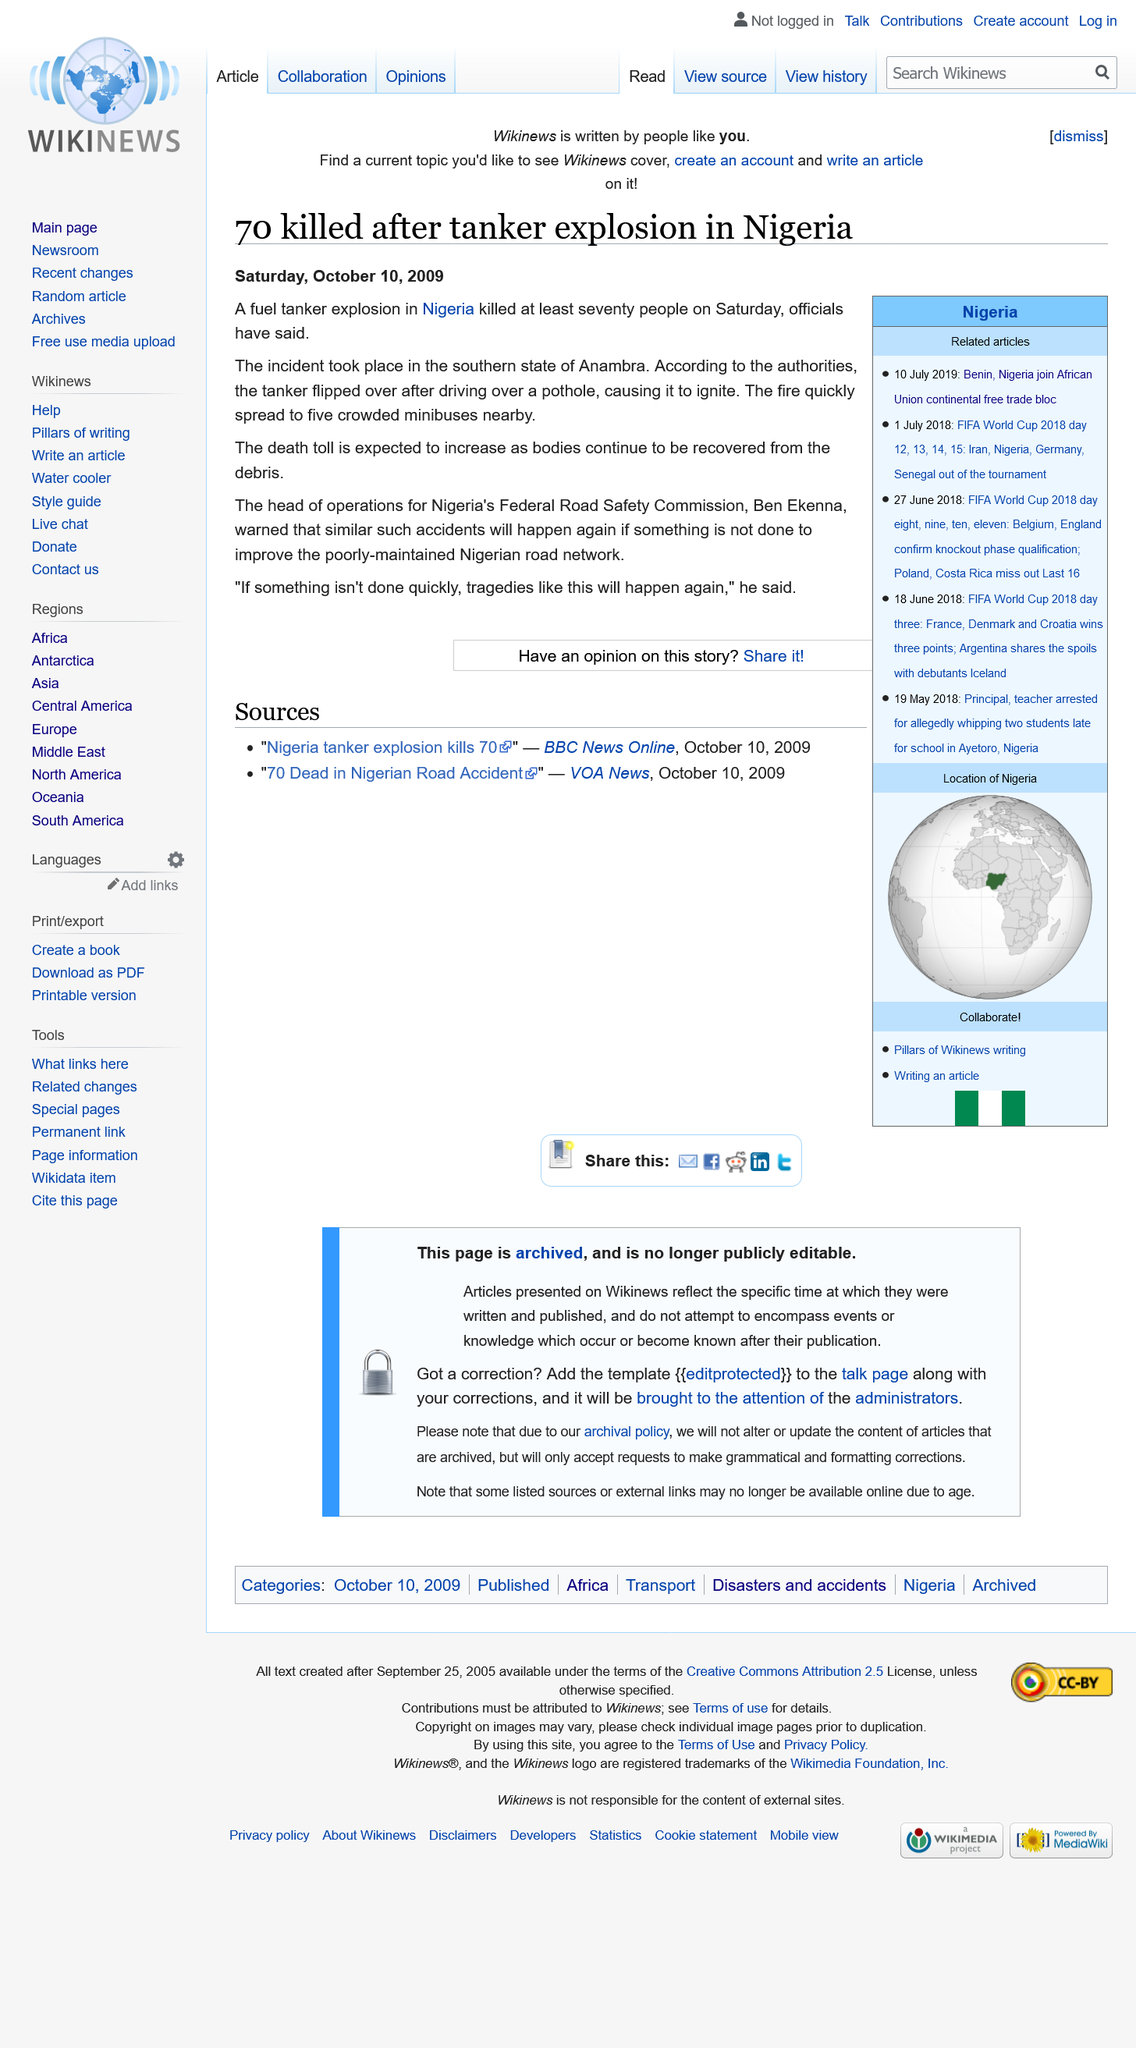Specify some key components in this picture. Anambra, a state in Nigeria, is located in the country of Nigeria. Ben Ekenna is the head of the Federal Road Safety Commission in Nigeria. Seventy people died in the fuel tanker explosion in Anambra in October 2009. 